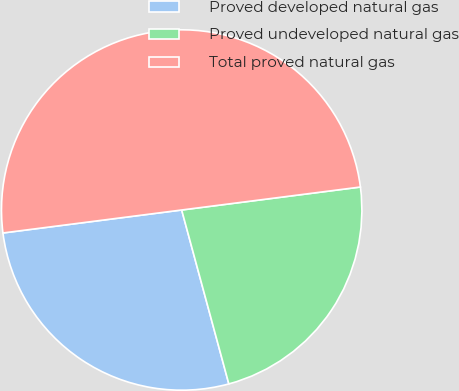Convert chart. <chart><loc_0><loc_0><loc_500><loc_500><pie_chart><fcel>Proved developed natural gas<fcel>Proved undeveloped natural gas<fcel>Total proved natural gas<nl><fcel>27.18%<fcel>22.82%<fcel>50.0%<nl></chart> 